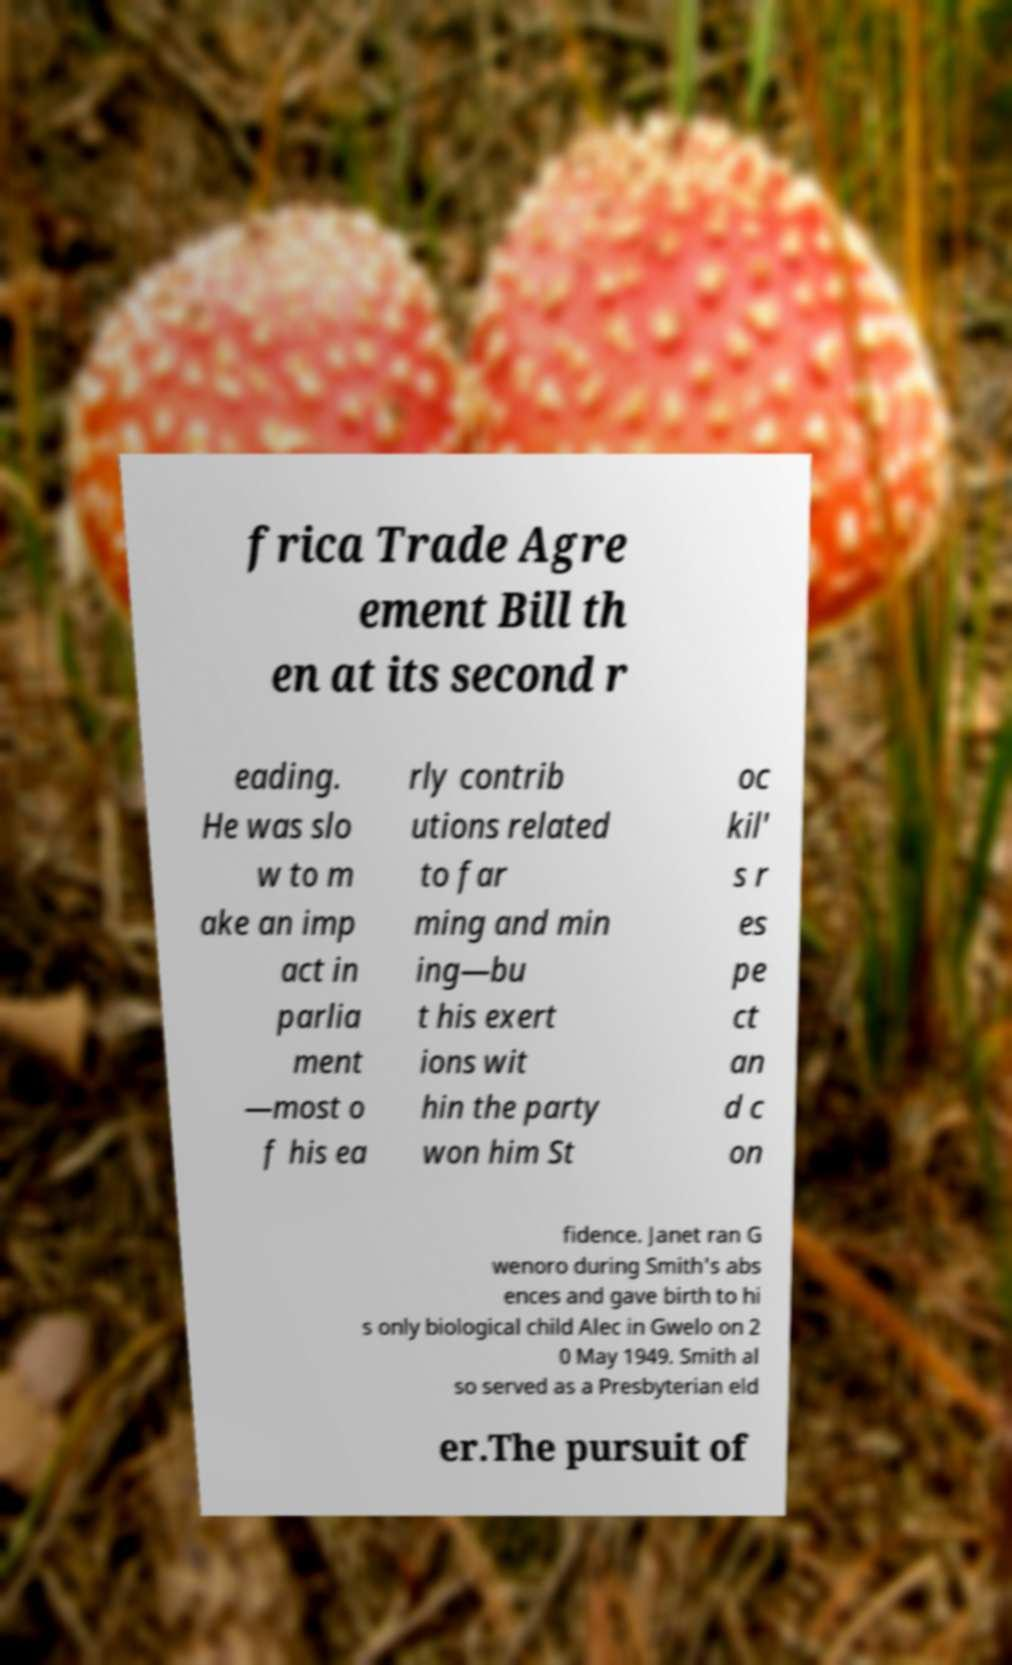For documentation purposes, I need the text within this image transcribed. Could you provide that? frica Trade Agre ement Bill th en at its second r eading. He was slo w to m ake an imp act in parlia ment —most o f his ea rly contrib utions related to far ming and min ing—bu t his exert ions wit hin the party won him St oc kil' s r es pe ct an d c on fidence. Janet ran G wenoro during Smith's abs ences and gave birth to hi s only biological child Alec in Gwelo on 2 0 May 1949. Smith al so served as a Presbyterian eld er.The pursuit of 